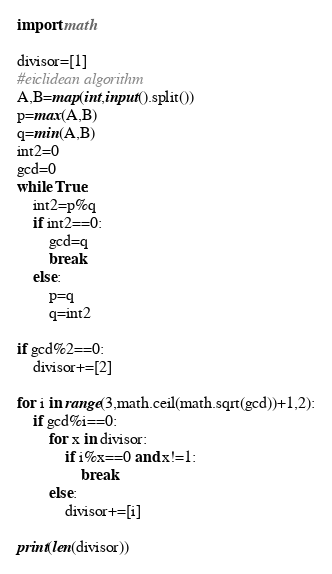Convert code to text. <code><loc_0><loc_0><loc_500><loc_500><_Python_>import math

divisor=[1]
#eiclidean algorithm
A,B=map(int,input().split())
p=max(A,B)
q=min(A,B)
int2=0
gcd=0
while True:
    int2=p%q
    if int2==0:
        gcd=q
        break
    else:
        p=q
        q=int2

if gcd%2==0:
    divisor+=[2]

for i in range(3,math.ceil(math.sqrt(gcd))+1,2):
    if gcd%i==0:
        for x in divisor:
            if i%x==0 and x!=1:
                break
        else:
            divisor+=[i]

print(len(divisor))
</code> 